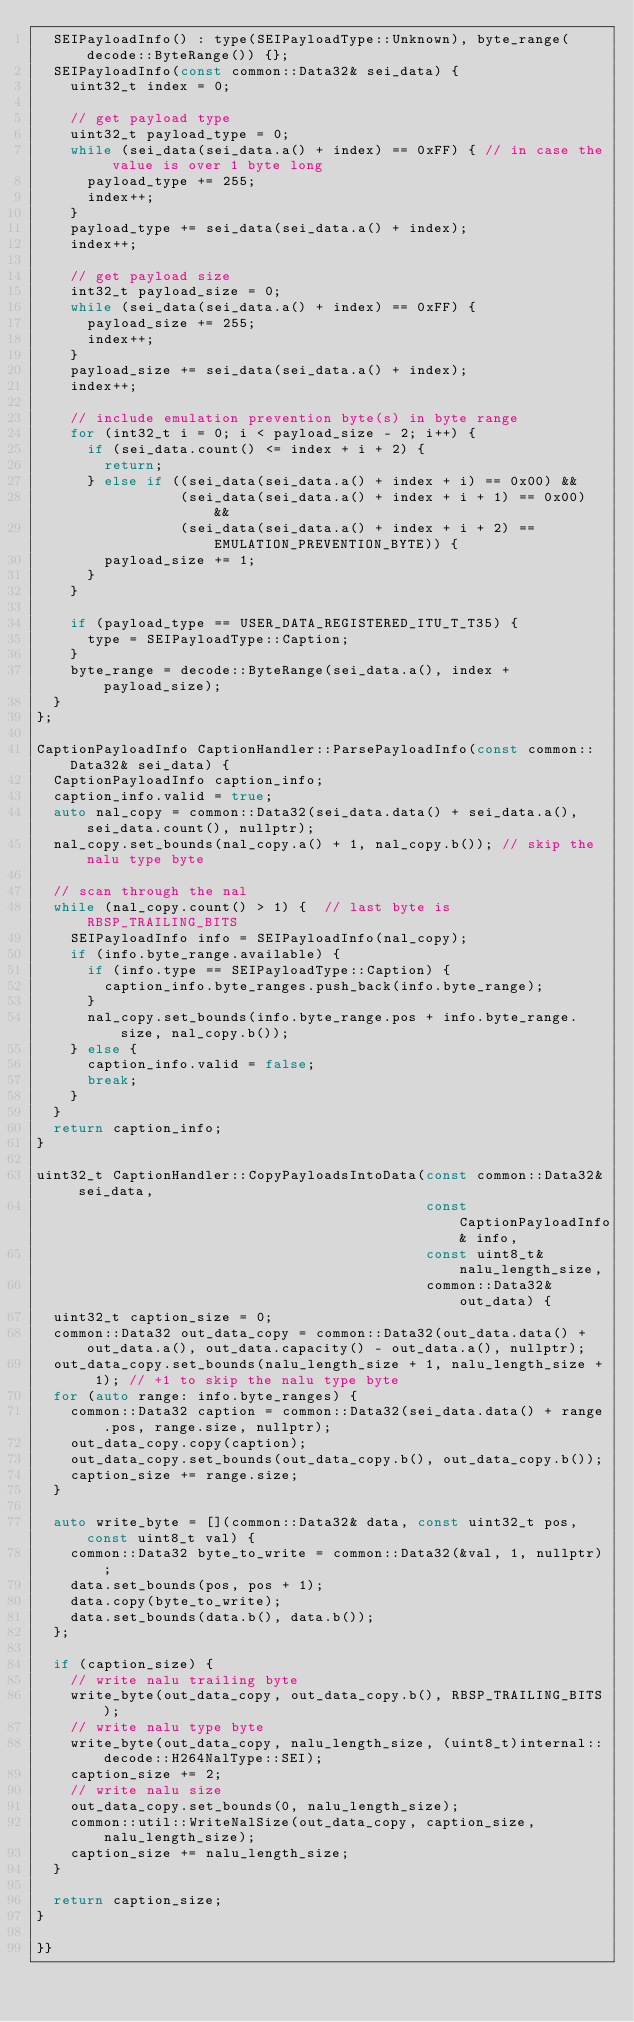Convert code to text. <code><loc_0><loc_0><loc_500><loc_500><_C++_>  SEIPayloadInfo() : type(SEIPayloadType::Unknown), byte_range(decode::ByteRange()) {};
  SEIPayloadInfo(const common::Data32& sei_data) {
    uint32_t index = 0;

    // get payload type
    uint32_t payload_type = 0;
    while (sei_data(sei_data.a() + index) == 0xFF) { // in case the value is over 1 byte long
      payload_type += 255;
      index++;
    }
    payload_type += sei_data(sei_data.a() + index);
    index++;

    // get payload size
    int32_t payload_size = 0;
    while (sei_data(sei_data.a() + index) == 0xFF) {
      payload_size += 255;
      index++;
    }
    payload_size += sei_data(sei_data.a() + index);
    index++;

    // include emulation prevention byte(s) in byte range
    for (int32_t i = 0; i < payload_size - 2; i++) {
      if (sei_data.count() <= index + i + 2) {
        return;
      } else if ((sei_data(sei_data.a() + index + i) == 0x00) &&
                 (sei_data(sei_data.a() + index + i + 1) == 0x00) &&
                 (sei_data(sei_data.a() + index + i + 2) == EMULATION_PREVENTION_BYTE)) {
        payload_size += 1;
      }
    }

    if (payload_type == USER_DATA_REGISTERED_ITU_T_T35) {
      type = SEIPayloadType::Caption;
    }
    byte_range = decode::ByteRange(sei_data.a(), index + payload_size);
  }
};

CaptionPayloadInfo CaptionHandler::ParsePayloadInfo(const common::Data32& sei_data) {
  CaptionPayloadInfo caption_info;
  caption_info.valid = true;
  auto nal_copy = common::Data32(sei_data.data() + sei_data.a(), sei_data.count(), nullptr);
  nal_copy.set_bounds(nal_copy.a() + 1, nal_copy.b()); // skip the nalu type byte

  // scan through the nal
  while (nal_copy.count() > 1) {  // last byte is RBSP_TRAILING_BITS
    SEIPayloadInfo info = SEIPayloadInfo(nal_copy);
    if (info.byte_range.available) {
      if (info.type == SEIPayloadType::Caption) {
        caption_info.byte_ranges.push_back(info.byte_range);
      }
      nal_copy.set_bounds(info.byte_range.pos + info.byte_range.size, nal_copy.b());
    } else {
      caption_info.valid = false;
      break;
    }
  }
  return caption_info;
}

uint32_t CaptionHandler::CopyPayloadsIntoData(const common::Data32& sei_data,
                                              const CaptionPayloadInfo& info,
                                              const uint8_t& nalu_length_size,
                                              common::Data32& out_data) {
  uint32_t caption_size = 0;
  common::Data32 out_data_copy = common::Data32(out_data.data() + out_data.a(), out_data.capacity() - out_data.a(), nullptr);
  out_data_copy.set_bounds(nalu_length_size + 1, nalu_length_size + 1); // +1 to skip the nalu type byte
  for (auto range: info.byte_ranges) {
    common::Data32 caption = common::Data32(sei_data.data() + range.pos, range.size, nullptr);
    out_data_copy.copy(caption);
    out_data_copy.set_bounds(out_data_copy.b(), out_data_copy.b());
    caption_size += range.size;
  }

  auto write_byte = [](common::Data32& data, const uint32_t pos, const uint8_t val) {
    common::Data32 byte_to_write = common::Data32(&val, 1, nullptr);
    data.set_bounds(pos, pos + 1);
    data.copy(byte_to_write);
    data.set_bounds(data.b(), data.b());
  };

  if (caption_size) {
    // write nalu trailing byte
    write_byte(out_data_copy, out_data_copy.b(), RBSP_TRAILING_BITS);
    // write nalu type byte
    write_byte(out_data_copy, nalu_length_size, (uint8_t)internal::decode::H264NalType::SEI);
    caption_size += 2;
    // write nalu size
    out_data_copy.set_bounds(0, nalu_length_size);
    common::util::WriteNalSize(out_data_copy, caption_size, nalu_length_size);
    caption_size += nalu_length_size;
  }

  return caption_size;
}

}}
</code> 